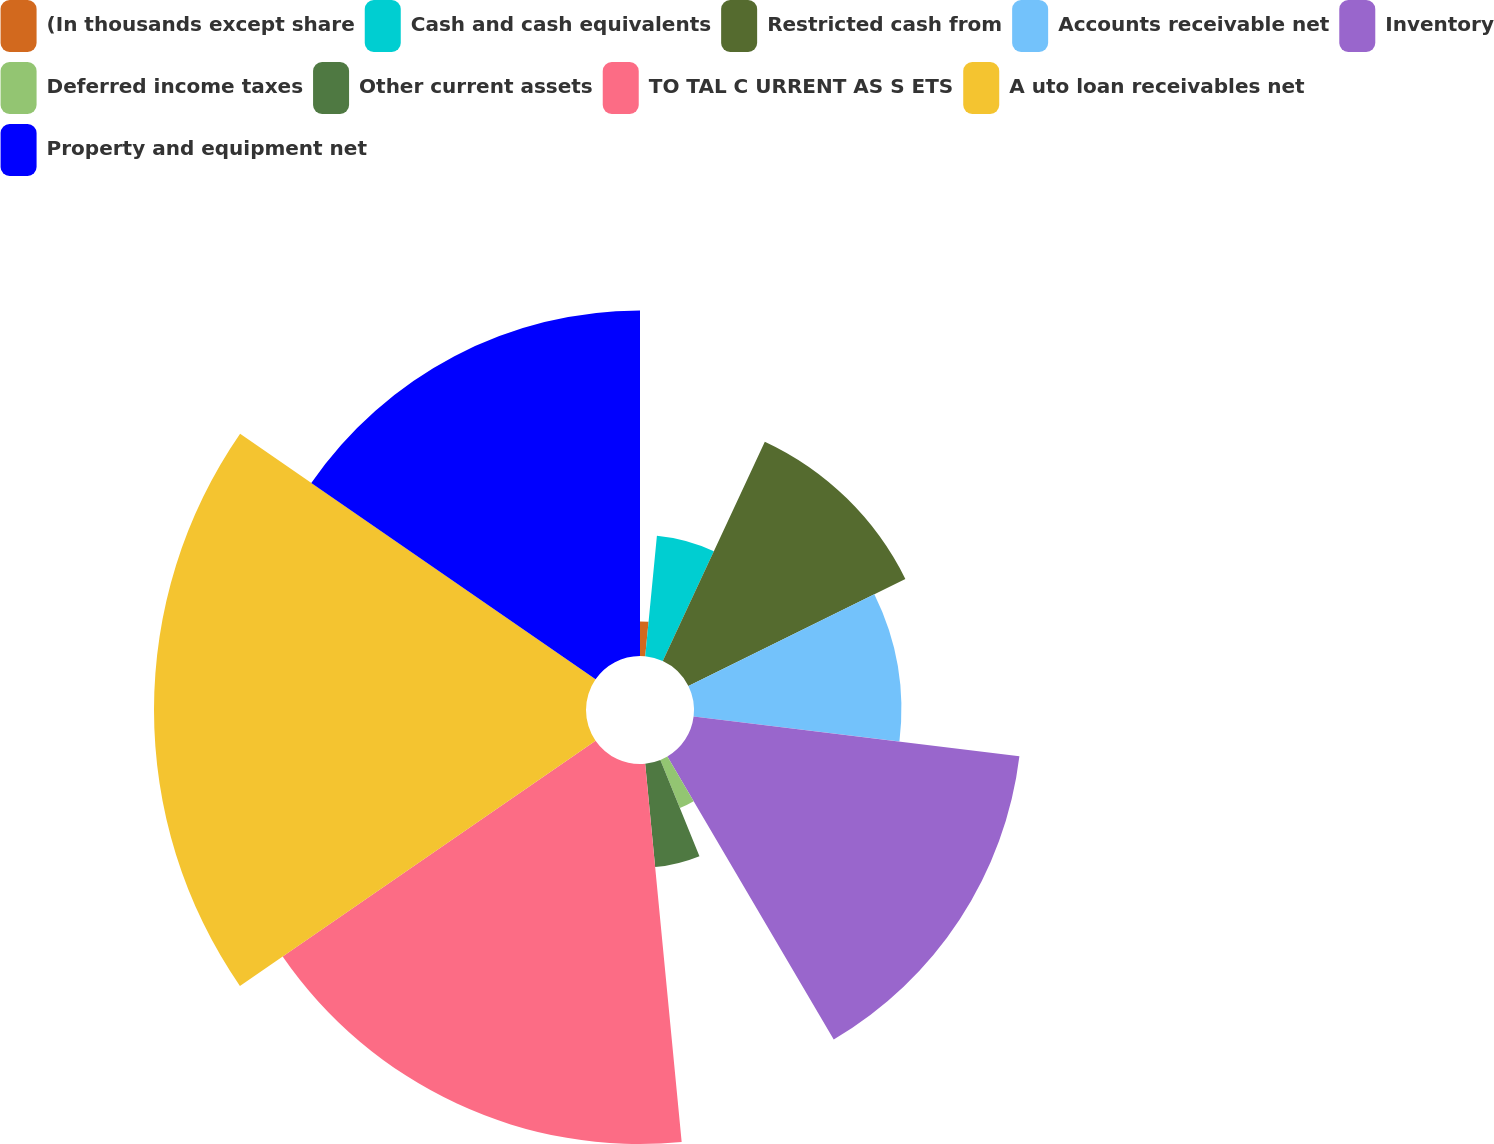Convert chart to OTSL. <chart><loc_0><loc_0><loc_500><loc_500><pie_chart><fcel>(In thousands except share<fcel>Cash and cash equivalents<fcel>Restricted cash from<fcel>Accounts receivable net<fcel>Inventory<fcel>Deferred income taxes<fcel>Other current assets<fcel>TO TAL C URRENT AS S ETS<fcel>A uto loan receivables net<fcel>Property and equipment net<nl><fcel>1.54%<fcel>5.39%<fcel>10.77%<fcel>9.23%<fcel>14.61%<fcel>2.31%<fcel>4.62%<fcel>16.92%<fcel>19.23%<fcel>15.38%<nl></chart> 